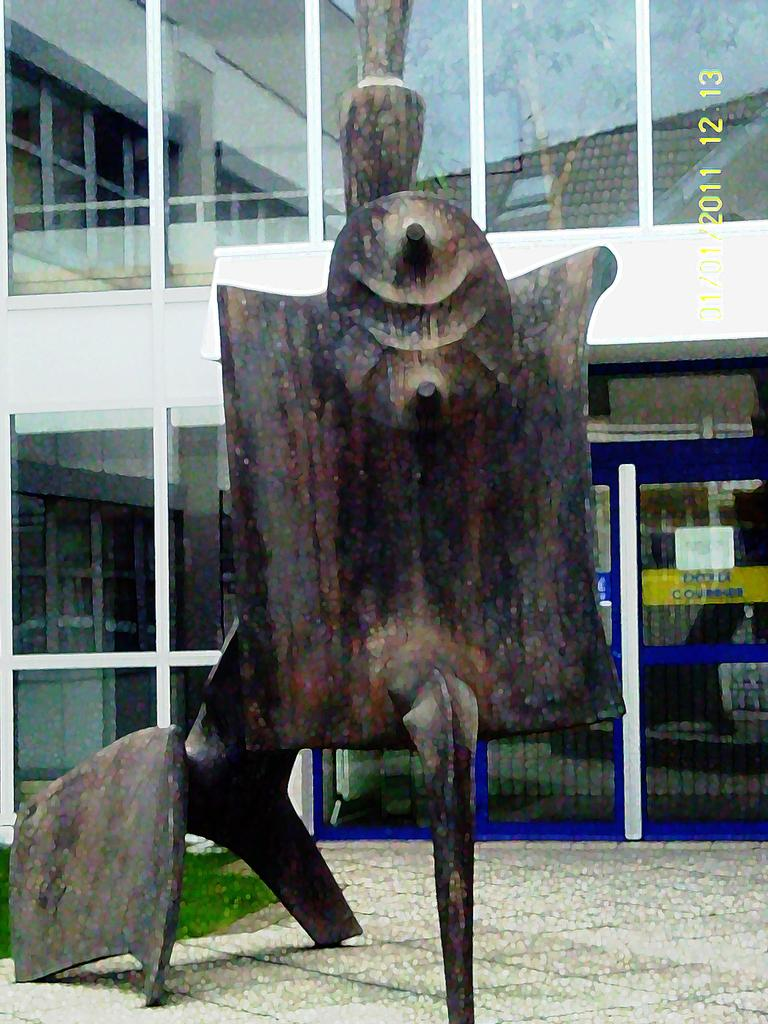What is the main subject of the image? There is a sculpture in the image. Where is the sculpture located? The sculpture is on the land. What can be seen in the background of the image? There is a building and a glass door in the background of the image. How many plants are surrounding the sculpture in the image? There is no mention of plants in the image, so we cannot determine the number of plants surrounding the sculpture. Are there any dogs visible in the image? There is no mention of dogs in the image, so we cannot determine if any dogs are visible. 